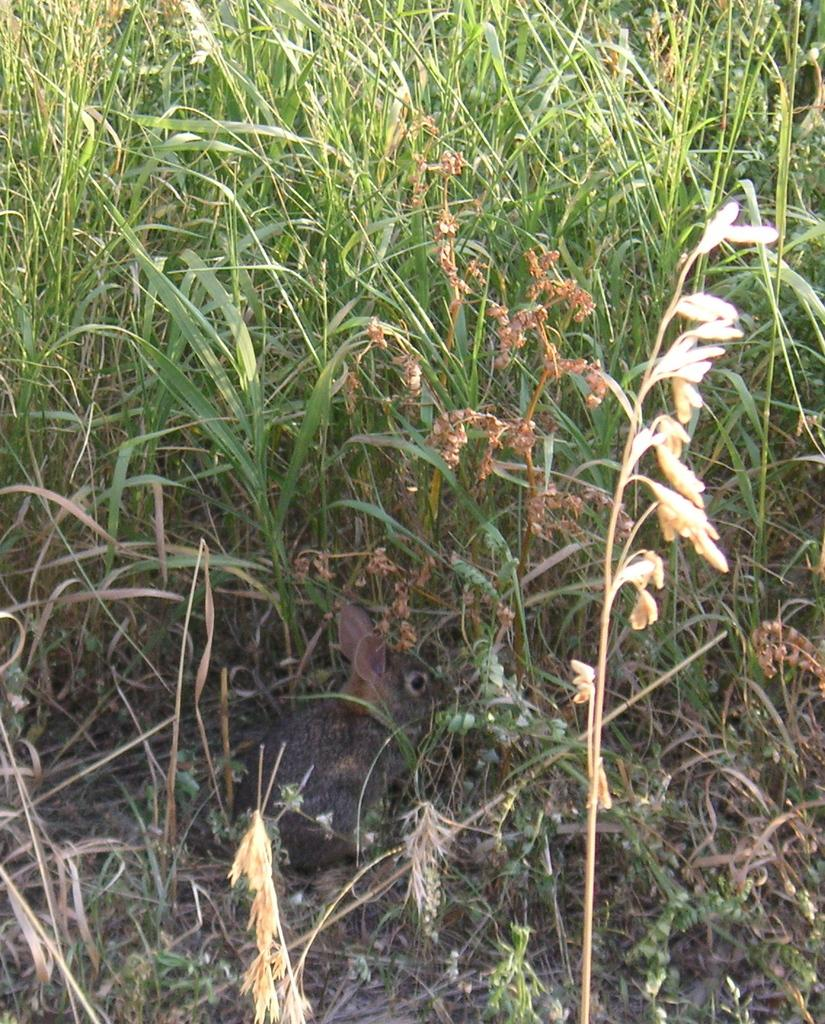What type of vegetation can be seen in the image? There is grass in the image. What is the monetary value of the art piece in the image? There is no art piece present in the image, and therefore no monetary value can be determined. 